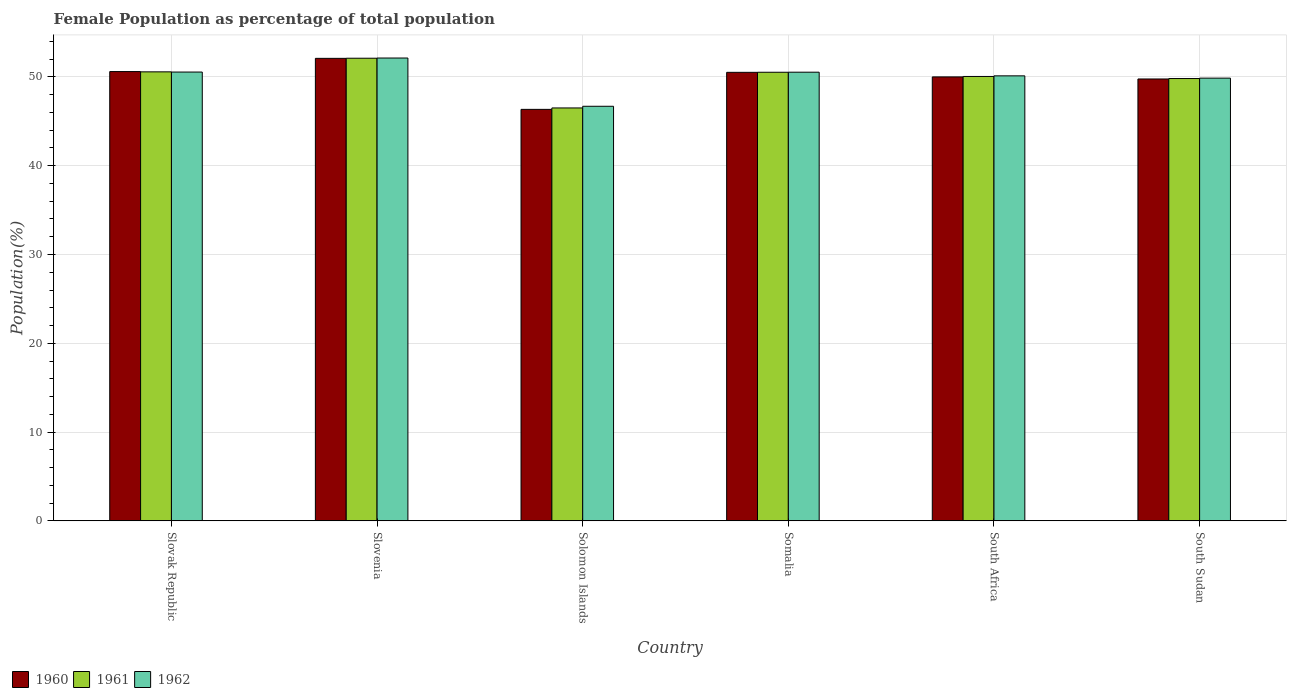Are the number of bars on each tick of the X-axis equal?
Your answer should be very brief. Yes. What is the label of the 2nd group of bars from the left?
Make the answer very short. Slovenia. What is the female population in in 1961 in South Africa?
Your answer should be very brief. 50.06. Across all countries, what is the maximum female population in in 1961?
Your answer should be compact. 52.11. Across all countries, what is the minimum female population in in 1961?
Your answer should be compact. 46.51. In which country was the female population in in 1962 maximum?
Offer a very short reply. Slovenia. In which country was the female population in in 1962 minimum?
Ensure brevity in your answer.  Solomon Islands. What is the total female population in in 1962 in the graph?
Provide a short and direct response. 299.91. What is the difference between the female population in in 1960 in Solomon Islands and that in Somalia?
Your answer should be compact. -4.17. What is the difference between the female population in in 1961 in South Sudan and the female population in in 1960 in South Africa?
Ensure brevity in your answer.  -0.18. What is the average female population in in 1961 per country?
Make the answer very short. 49.93. What is the difference between the female population in of/in 1962 and female population in of/in 1960 in South Sudan?
Your answer should be very brief. 0.1. In how many countries, is the female population in in 1960 greater than 12 %?
Your answer should be compact. 6. What is the ratio of the female population in in 1961 in Slovak Republic to that in Somalia?
Ensure brevity in your answer.  1. Is the female population in in 1960 in Solomon Islands less than that in Somalia?
Offer a terse response. Yes. Is the difference between the female population in in 1962 in Slovenia and Somalia greater than the difference between the female population in in 1960 in Slovenia and Somalia?
Your response must be concise. Yes. What is the difference between the highest and the second highest female population in in 1960?
Make the answer very short. -1.49. What is the difference between the highest and the lowest female population in in 1960?
Keep it short and to the point. 5.75. What does the 3rd bar from the left in Slovenia represents?
Offer a very short reply. 1962. What does the 1st bar from the right in Solomon Islands represents?
Offer a terse response. 1962. Are all the bars in the graph horizontal?
Your answer should be very brief. No. How many countries are there in the graph?
Your response must be concise. 6. Does the graph contain any zero values?
Your answer should be compact. No. How many legend labels are there?
Ensure brevity in your answer.  3. What is the title of the graph?
Your answer should be compact. Female Population as percentage of total population. Does "1999" appear as one of the legend labels in the graph?
Your answer should be very brief. No. What is the label or title of the X-axis?
Provide a short and direct response. Country. What is the label or title of the Y-axis?
Your answer should be compact. Population(%). What is the Population(%) of 1960 in Slovak Republic?
Give a very brief answer. 50.61. What is the Population(%) of 1961 in Slovak Republic?
Offer a very short reply. 50.57. What is the Population(%) of 1962 in Slovak Republic?
Your response must be concise. 50.55. What is the Population(%) of 1960 in Slovenia?
Make the answer very short. 52.1. What is the Population(%) in 1961 in Slovenia?
Provide a succinct answer. 52.11. What is the Population(%) in 1962 in Slovenia?
Make the answer very short. 52.13. What is the Population(%) in 1960 in Solomon Islands?
Your response must be concise. 46.35. What is the Population(%) in 1961 in Solomon Islands?
Your answer should be very brief. 46.51. What is the Population(%) of 1962 in Solomon Islands?
Offer a terse response. 46.7. What is the Population(%) of 1960 in Somalia?
Provide a short and direct response. 50.52. What is the Population(%) of 1961 in Somalia?
Your answer should be compact. 50.53. What is the Population(%) in 1962 in Somalia?
Keep it short and to the point. 50.54. What is the Population(%) of 1960 in South Africa?
Provide a short and direct response. 50.01. What is the Population(%) in 1961 in South Africa?
Your answer should be compact. 50.06. What is the Population(%) in 1962 in South Africa?
Provide a short and direct response. 50.12. What is the Population(%) of 1960 in South Sudan?
Your answer should be compact. 49.77. What is the Population(%) in 1961 in South Sudan?
Your answer should be very brief. 49.82. What is the Population(%) in 1962 in South Sudan?
Ensure brevity in your answer.  49.87. Across all countries, what is the maximum Population(%) in 1960?
Provide a short and direct response. 52.1. Across all countries, what is the maximum Population(%) of 1961?
Provide a short and direct response. 52.11. Across all countries, what is the maximum Population(%) in 1962?
Keep it short and to the point. 52.13. Across all countries, what is the minimum Population(%) in 1960?
Offer a very short reply. 46.35. Across all countries, what is the minimum Population(%) in 1961?
Your answer should be compact. 46.51. Across all countries, what is the minimum Population(%) of 1962?
Offer a terse response. 46.7. What is the total Population(%) in 1960 in the graph?
Your answer should be very brief. 299.35. What is the total Population(%) in 1961 in the graph?
Offer a very short reply. 299.6. What is the total Population(%) of 1962 in the graph?
Your answer should be very brief. 299.91. What is the difference between the Population(%) in 1960 in Slovak Republic and that in Slovenia?
Keep it short and to the point. -1.49. What is the difference between the Population(%) of 1961 in Slovak Republic and that in Slovenia?
Keep it short and to the point. -1.53. What is the difference between the Population(%) in 1962 in Slovak Republic and that in Slovenia?
Offer a very short reply. -1.58. What is the difference between the Population(%) of 1960 in Slovak Republic and that in Solomon Islands?
Keep it short and to the point. 4.26. What is the difference between the Population(%) in 1961 in Slovak Republic and that in Solomon Islands?
Your response must be concise. 4.07. What is the difference between the Population(%) in 1962 in Slovak Republic and that in Solomon Islands?
Your answer should be compact. 3.85. What is the difference between the Population(%) in 1960 in Slovak Republic and that in Somalia?
Offer a terse response. 0.09. What is the difference between the Population(%) in 1961 in Slovak Republic and that in Somalia?
Give a very brief answer. 0.05. What is the difference between the Population(%) of 1962 in Slovak Republic and that in Somalia?
Ensure brevity in your answer.  0.01. What is the difference between the Population(%) of 1960 in Slovak Republic and that in South Africa?
Provide a succinct answer. 0.6. What is the difference between the Population(%) of 1961 in Slovak Republic and that in South Africa?
Your answer should be very brief. 0.52. What is the difference between the Population(%) in 1962 in Slovak Republic and that in South Africa?
Your response must be concise. 0.43. What is the difference between the Population(%) in 1960 in Slovak Republic and that in South Sudan?
Offer a terse response. 0.83. What is the difference between the Population(%) of 1961 in Slovak Republic and that in South Sudan?
Your answer should be compact. 0.75. What is the difference between the Population(%) of 1962 in Slovak Republic and that in South Sudan?
Your answer should be compact. 0.68. What is the difference between the Population(%) of 1960 in Slovenia and that in Solomon Islands?
Offer a very short reply. 5.75. What is the difference between the Population(%) of 1961 in Slovenia and that in Solomon Islands?
Provide a short and direct response. 5.6. What is the difference between the Population(%) of 1962 in Slovenia and that in Solomon Islands?
Offer a terse response. 5.44. What is the difference between the Population(%) in 1960 in Slovenia and that in Somalia?
Make the answer very short. 1.58. What is the difference between the Population(%) of 1961 in Slovenia and that in Somalia?
Offer a very short reply. 1.58. What is the difference between the Population(%) in 1962 in Slovenia and that in Somalia?
Provide a succinct answer. 1.6. What is the difference between the Population(%) of 1960 in Slovenia and that in South Africa?
Offer a terse response. 2.09. What is the difference between the Population(%) in 1961 in Slovenia and that in South Africa?
Offer a very short reply. 2.05. What is the difference between the Population(%) of 1962 in Slovenia and that in South Africa?
Give a very brief answer. 2.01. What is the difference between the Population(%) in 1960 in Slovenia and that in South Sudan?
Give a very brief answer. 2.32. What is the difference between the Population(%) of 1961 in Slovenia and that in South Sudan?
Your answer should be very brief. 2.29. What is the difference between the Population(%) of 1962 in Slovenia and that in South Sudan?
Give a very brief answer. 2.27. What is the difference between the Population(%) of 1960 in Solomon Islands and that in Somalia?
Provide a succinct answer. -4.17. What is the difference between the Population(%) of 1961 in Solomon Islands and that in Somalia?
Provide a short and direct response. -4.02. What is the difference between the Population(%) of 1962 in Solomon Islands and that in Somalia?
Keep it short and to the point. -3.84. What is the difference between the Population(%) of 1960 in Solomon Islands and that in South Africa?
Provide a short and direct response. -3.66. What is the difference between the Population(%) in 1961 in Solomon Islands and that in South Africa?
Provide a short and direct response. -3.55. What is the difference between the Population(%) of 1962 in Solomon Islands and that in South Africa?
Your answer should be very brief. -3.43. What is the difference between the Population(%) in 1960 in Solomon Islands and that in South Sudan?
Your response must be concise. -3.42. What is the difference between the Population(%) in 1961 in Solomon Islands and that in South Sudan?
Give a very brief answer. -3.31. What is the difference between the Population(%) in 1962 in Solomon Islands and that in South Sudan?
Your answer should be very brief. -3.17. What is the difference between the Population(%) in 1960 in Somalia and that in South Africa?
Provide a short and direct response. 0.51. What is the difference between the Population(%) of 1961 in Somalia and that in South Africa?
Offer a very short reply. 0.47. What is the difference between the Population(%) in 1962 in Somalia and that in South Africa?
Provide a succinct answer. 0.41. What is the difference between the Population(%) in 1960 in Somalia and that in South Sudan?
Make the answer very short. 0.75. What is the difference between the Population(%) of 1961 in Somalia and that in South Sudan?
Make the answer very short. 0.71. What is the difference between the Population(%) in 1962 in Somalia and that in South Sudan?
Provide a succinct answer. 0.67. What is the difference between the Population(%) in 1960 in South Africa and that in South Sudan?
Keep it short and to the point. 0.23. What is the difference between the Population(%) in 1961 in South Africa and that in South Sudan?
Keep it short and to the point. 0.23. What is the difference between the Population(%) in 1962 in South Africa and that in South Sudan?
Provide a short and direct response. 0.26. What is the difference between the Population(%) in 1960 in Slovak Republic and the Population(%) in 1961 in Slovenia?
Ensure brevity in your answer.  -1.5. What is the difference between the Population(%) of 1960 in Slovak Republic and the Population(%) of 1962 in Slovenia?
Keep it short and to the point. -1.53. What is the difference between the Population(%) in 1961 in Slovak Republic and the Population(%) in 1962 in Slovenia?
Make the answer very short. -1.56. What is the difference between the Population(%) of 1960 in Slovak Republic and the Population(%) of 1961 in Solomon Islands?
Your answer should be compact. 4.1. What is the difference between the Population(%) of 1960 in Slovak Republic and the Population(%) of 1962 in Solomon Islands?
Ensure brevity in your answer.  3.91. What is the difference between the Population(%) of 1961 in Slovak Republic and the Population(%) of 1962 in Solomon Islands?
Your response must be concise. 3.88. What is the difference between the Population(%) in 1960 in Slovak Republic and the Population(%) in 1961 in Somalia?
Offer a very short reply. 0.08. What is the difference between the Population(%) in 1960 in Slovak Republic and the Population(%) in 1962 in Somalia?
Offer a terse response. 0.07. What is the difference between the Population(%) in 1961 in Slovak Republic and the Population(%) in 1962 in Somalia?
Offer a terse response. 0.04. What is the difference between the Population(%) of 1960 in Slovak Republic and the Population(%) of 1961 in South Africa?
Your answer should be very brief. 0.55. What is the difference between the Population(%) of 1960 in Slovak Republic and the Population(%) of 1962 in South Africa?
Give a very brief answer. 0.48. What is the difference between the Population(%) in 1961 in Slovak Republic and the Population(%) in 1962 in South Africa?
Your response must be concise. 0.45. What is the difference between the Population(%) of 1960 in Slovak Republic and the Population(%) of 1961 in South Sudan?
Offer a very short reply. 0.78. What is the difference between the Population(%) in 1960 in Slovak Republic and the Population(%) in 1962 in South Sudan?
Provide a succinct answer. 0.74. What is the difference between the Population(%) of 1961 in Slovak Republic and the Population(%) of 1962 in South Sudan?
Keep it short and to the point. 0.71. What is the difference between the Population(%) in 1960 in Slovenia and the Population(%) in 1961 in Solomon Islands?
Make the answer very short. 5.59. What is the difference between the Population(%) in 1960 in Slovenia and the Population(%) in 1962 in Solomon Islands?
Provide a succinct answer. 5.4. What is the difference between the Population(%) in 1961 in Slovenia and the Population(%) in 1962 in Solomon Islands?
Offer a very short reply. 5.41. What is the difference between the Population(%) in 1960 in Slovenia and the Population(%) in 1961 in Somalia?
Make the answer very short. 1.57. What is the difference between the Population(%) of 1960 in Slovenia and the Population(%) of 1962 in Somalia?
Offer a terse response. 1.56. What is the difference between the Population(%) in 1961 in Slovenia and the Population(%) in 1962 in Somalia?
Give a very brief answer. 1.57. What is the difference between the Population(%) of 1960 in Slovenia and the Population(%) of 1961 in South Africa?
Ensure brevity in your answer.  2.04. What is the difference between the Population(%) in 1960 in Slovenia and the Population(%) in 1962 in South Africa?
Provide a short and direct response. 1.97. What is the difference between the Population(%) of 1961 in Slovenia and the Population(%) of 1962 in South Africa?
Offer a very short reply. 1.98. What is the difference between the Population(%) in 1960 in Slovenia and the Population(%) in 1961 in South Sudan?
Offer a terse response. 2.27. What is the difference between the Population(%) of 1960 in Slovenia and the Population(%) of 1962 in South Sudan?
Give a very brief answer. 2.23. What is the difference between the Population(%) in 1961 in Slovenia and the Population(%) in 1962 in South Sudan?
Offer a very short reply. 2.24. What is the difference between the Population(%) of 1960 in Solomon Islands and the Population(%) of 1961 in Somalia?
Provide a succinct answer. -4.18. What is the difference between the Population(%) in 1960 in Solomon Islands and the Population(%) in 1962 in Somalia?
Provide a short and direct response. -4.19. What is the difference between the Population(%) in 1961 in Solomon Islands and the Population(%) in 1962 in Somalia?
Give a very brief answer. -4.03. What is the difference between the Population(%) in 1960 in Solomon Islands and the Population(%) in 1961 in South Africa?
Your answer should be very brief. -3.71. What is the difference between the Population(%) in 1960 in Solomon Islands and the Population(%) in 1962 in South Africa?
Your response must be concise. -3.78. What is the difference between the Population(%) of 1961 in Solomon Islands and the Population(%) of 1962 in South Africa?
Give a very brief answer. -3.62. What is the difference between the Population(%) of 1960 in Solomon Islands and the Population(%) of 1961 in South Sudan?
Make the answer very short. -3.47. What is the difference between the Population(%) in 1960 in Solomon Islands and the Population(%) in 1962 in South Sudan?
Ensure brevity in your answer.  -3.52. What is the difference between the Population(%) of 1961 in Solomon Islands and the Population(%) of 1962 in South Sudan?
Ensure brevity in your answer.  -3.36. What is the difference between the Population(%) of 1960 in Somalia and the Population(%) of 1961 in South Africa?
Ensure brevity in your answer.  0.46. What is the difference between the Population(%) in 1960 in Somalia and the Population(%) in 1962 in South Africa?
Keep it short and to the point. 0.39. What is the difference between the Population(%) in 1961 in Somalia and the Population(%) in 1962 in South Africa?
Your response must be concise. 0.4. What is the difference between the Population(%) in 1960 in Somalia and the Population(%) in 1961 in South Sudan?
Your answer should be very brief. 0.7. What is the difference between the Population(%) in 1960 in Somalia and the Population(%) in 1962 in South Sudan?
Offer a terse response. 0.65. What is the difference between the Population(%) of 1961 in Somalia and the Population(%) of 1962 in South Sudan?
Keep it short and to the point. 0.66. What is the difference between the Population(%) in 1960 in South Africa and the Population(%) in 1961 in South Sudan?
Provide a succinct answer. 0.18. What is the difference between the Population(%) in 1960 in South Africa and the Population(%) in 1962 in South Sudan?
Provide a short and direct response. 0.14. What is the difference between the Population(%) of 1961 in South Africa and the Population(%) of 1962 in South Sudan?
Provide a short and direct response. 0.19. What is the average Population(%) of 1960 per country?
Offer a terse response. 49.89. What is the average Population(%) of 1961 per country?
Your answer should be compact. 49.93. What is the average Population(%) in 1962 per country?
Provide a succinct answer. 49.98. What is the difference between the Population(%) in 1960 and Population(%) in 1961 in Slovak Republic?
Keep it short and to the point. 0.03. What is the difference between the Population(%) in 1960 and Population(%) in 1962 in Slovak Republic?
Make the answer very short. 0.05. What is the difference between the Population(%) of 1961 and Population(%) of 1962 in Slovak Republic?
Provide a succinct answer. 0.02. What is the difference between the Population(%) in 1960 and Population(%) in 1961 in Slovenia?
Keep it short and to the point. -0.01. What is the difference between the Population(%) in 1960 and Population(%) in 1962 in Slovenia?
Provide a short and direct response. -0.04. What is the difference between the Population(%) of 1961 and Population(%) of 1962 in Slovenia?
Make the answer very short. -0.02. What is the difference between the Population(%) of 1960 and Population(%) of 1961 in Solomon Islands?
Your answer should be compact. -0.16. What is the difference between the Population(%) of 1960 and Population(%) of 1962 in Solomon Islands?
Offer a very short reply. -0.35. What is the difference between the Population(%) in 1961 and Population(%) in 1962 in Solomon Islands?
Your response must be concise. -0.19. What is the difference between the Population(%) in 1960 and Population(%) in 1961 in Somalia?
Provide a succinct answer. -0.01. What is the difference between the Population(%) of 1960 and Population(%) of 1962 in Somalia?
Your answer should be very brief. -0.02. What is the difference between the Population(%) in 1961 and Population(%) in 1962 in Somalia?
Offer a very short reply. -0.01. What is the difference between the Population(%) of 1960 and Population(%) of 1961 in South Africa?
Your answer should be very brief. -0.05. What is the difference between the Population(%) of 1960 and Population(%) of 1962 in South Africa?
Your answer should be compact. -0.12. What is the difference between the Population(%) of 1961 and Population(%) of 1962 in South Africa?
Provide a succinct answer. -0.07. What is the difference between the Population(%) in 1960 and Population(%) in 1961 in South Sudan?
Offer a terse response. -0.05. What is the difference between the Population(%) of 1960 and Population(%) of 1962 in South Sudan?
Provide a short and direct response. -0.1. What is the difference between the Population(%) of 1961 and Population(%) of 1962 in South Sudan?
Your answer should be very brief. -0.05. What is the ratio of the Population(%) in 1960 in Slovak Republic to that in Slovenia?
Offer a very short reply. 0.97. What is the ratio of the Population(%) in 1961 in Slovak Republic to that in Slovenia?
Your answer should be very brief. 0.97. What is the ratio of the Population(%) in 1962 in Slovak Republic to that in Slovenia?
Your answer should be very brief. 0.97. What is the ratio of the Population(%) in 1960 in Slovak Republic to that in Solomon Islands?
Your response must be concise. 1.09. What is the ratio of the Population(%) of 1961 in Slovak Republic to that in Solomon Islands?
Offer a terse response. 1.09. What is the ratio of the Population(%) in 1962 in Slovak Republic to that in Solomon Islands?
Provide a succinct answer. 1.08. What is the ratio of the Population(%) of 1960 in Slovak Republic to that in Somalia?
Your answer should be very brief. 1. What is the ratio of the Population(%) in 1962 in Slovak Republic to that in Somalia?
Provide a short and direct response. 1. What is the ratio of the Population(%) of 1960 in Slovak Republic to that in South Africa?
Provide a succinct answer. 1.01. What is the ratio of the Population(%) of 1961 in Slovak Republic to that in South Africa?
Ensure brevity in your answer.  1.01. What is the ratio of the Population(%) of 1962 in Slovak Republic to that in South Africa?
Your answer should be very brief. 1.01. What is the ratio of the Population(%) in 1960 in Slovak Republic to that in South Sudan?
Give a very brief answer. 1.02. What is the ratio of the Population(%) of 1961 in Slovak Republic to that in South Sudan?
Make the answer very short. 1.02. What is the ratio of the Population(%) of 1962 in Slovak Republic to that in South Sudan?
Offer a very short reply. 1.01. What is the ratio of the Population(%) of 1960 in Slovenia to that in Solomon Islands?
Keep it short and to the point. 1.12. What is the ratio of the Population(%) of 1961 in Slovenia to that in Solomon Islands?
Provide a succinct answer. 1.12. What is the ratio of the Population(%) in 1962 in Slovenia to that in Solomon Islands?
Your answer should be compact. 1.12. What is the ratio of the Population(%) of 1960 in Slovenia to that in Somalia?
Your answer should be compact. 1.03. What is the ratio of the Population(%) of 1961 in Slovenia to that in Somalia?
Provide a succinct answer. 1.03. What is the ratio of the Population(%) in 1962 in Slovenia to that in Somalia?
Keep it short and to the point. 1.03. What is the ratio of the Population(%) of 1960 in Slovenia to that in South Africa?
Provide a succinct answer. 1.04. What is the ratio of the Population(%) in 1961 in Slovenia to that in South Africa?
Offer a terse response. 1.04. What is the ratio of the Population(%) of 1962 in Slovenia to that in South Africa?
Offer a terse response. 1.04. What is the ratio of the Population(%) in 1960 in Slovenia to that in South Sudan?
Provide a succinct answer. 1.05. What is the ratio of the Population(%) of 1961 in Slovenia to that in South Sudan?
Your answer should be compact. 1.05. What is the ratio of the Population(%) of 1962 in Slovenia to that in South Sudan?
Offer a terse response. 1.05. What is the ratio of the Population(%) in 1960 in Solomon Islands to that in Somalia?
Your answer should be compact. 0.92. What is the ratio of the Population(%) of 1961 in Solomon Islands to that in Somalia?
Ensure brevity in your answer.  0.92. What is the ratio of the Population(%) in 1962 in Solomon Islands to that in Somalia?
Your response must be concise. 0.92. What is the ratio of the Population(%) of 1960 in Solomon Islands to that in South Africa?
Your response must be concise. 0.93. What is the ratio of the Population(%) of 1961 in Solomon Islands to that in South Africa?
Make the answer very short. 0.93. What is the ratio of the Population(%) of 1962 in Solomon Islands to that in South Africa?
Make the answer very short. 0.93. What is the ratio of the Population(%) of 1960 in Solomon Islands to that in South Sudan?
Keep it short and to the point. 0.93. What is the ratio of the Population(%) in 1961 in Solomon Islands to that in South Sudan?
Keep it short and to the point. 0.93. What is the ratio of the Population(%) of 1962 in Solomon Islands to that in South Sudan?
Keep it short and to the point. 0.94. What is the ratio of the Population(%) in 1960 in Somalia to that in South Africa?
Your answer should be compact. 1.01. What is the ratio of the Population(%) in 1961 in Somalia to that in South Africa?
Make the answer very short. 1.01. What is the ratio of the Population(%) of 1962 in Somalia to that in South Africa?
Offer a terse response. 1.01. What is the ratio of the Population(%) in 1961 in Somalia to that in South Sudan?
Your answer should be very brief. 1.01. What is the ratio of the Population(%) of 1962 in Somalia to that in South Sudan?
Your response must be concise. 1.01. What is the ratio of the Population(%) of 1960 in South Africa to that in South Sudan?
Give a very brief answer. 1. What is the ratio of the Population(%) in 1961 in South Africa to that in South Sudan?
Make the answer very short. 1. What is the ratio of the Population(%) in 1962 in South Africa to that in South Sudan?
Provide a succinct answer. 1.01. What is the difference between the highest and the second highest Population(%) of 1960?
Your answer should be very brief. 1.49. What is the difference between the highest and the second highest Population(%) in 1961?
Your answer should be compact. 1.53. What is the difference between the highest and the second highest Population(%) in 1962?
Offer a terse response. 1.58. What is the difference between the highest and the lowest Population(%) in 1960?
Offer a terse response. 5.75. What is the difference between the highest and the lowest Population(%) of 1961?
Provide a succinct answer. 5.6. What is the difference between the highest and the lowest Population(%) in 1962?
Your answer should be compact. 5.44. 